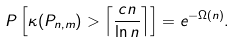<formula> <loc_0><loc_0><loc_500><loc_500>P \left [ \kappa ( P _ { n , m } ) > \left \lceil \frac { c n } { \ln n } \right \rceil \right ] = e ^ { - \Omega ( n ) } .</formula> 